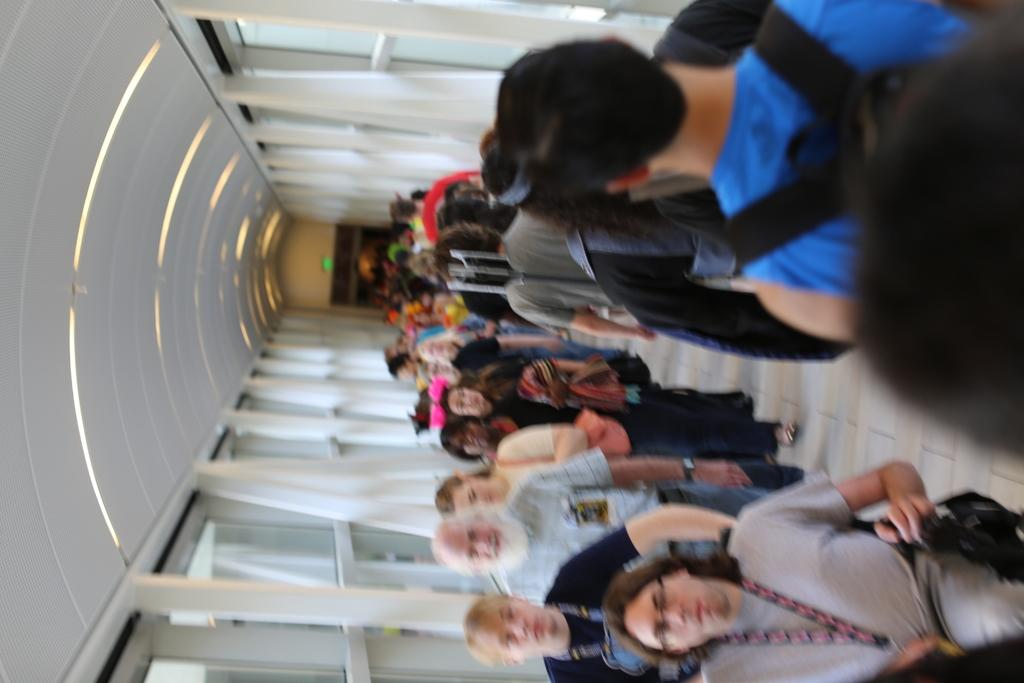What can be seen running through the image? There is a path in the image. What is happening on the path? There are multiple people on the path. What is above the path in the image? There is a ceiling visible in the image. What can be seen on the ceiling? There are lights on the ceiling. What language are the people on the path speaking in the image? There is no information about the language being spoken by the people in the image. What type of dress is the person in the image wearing? There is no person specifically mentioned in the image, only multiple people on the path. 